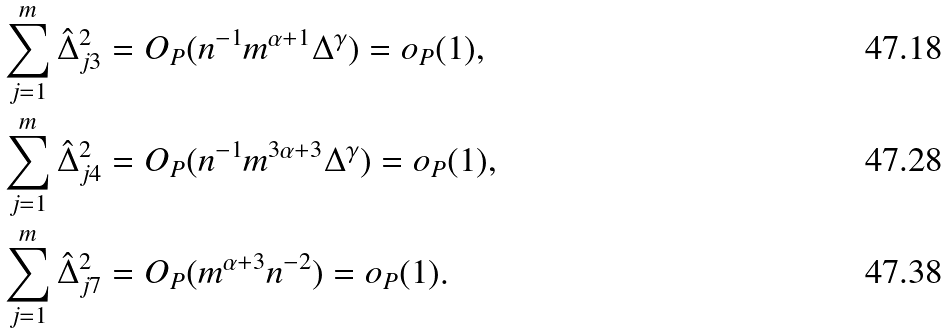Convert formula to latex. <formula><loc_0><loc_0><loc_500><loc_500>\sum _ { j = 1 } ^ { m } \hat { \Delta } _ { j 3 } ^ { 2 } & = O _ { P } ( n ^ { - 1 } m ^ { \alpha + 1 } \Delta ^ { \gamma } ) = o _ { P } ( 1 ) , \\ \sum _ { j = 1 } ^ { m } \hat { \Delta } _ { j 4 } ^ { 2 } & = O _ { P } ( n ^ { - 1 } m ^ { 3 \alpha + 3 } \Delta ^ { \gamma } ) = o _ { P } ( 1 ) , \\ \sum _ { j = 1 } ^ { m } \hat { \Delta } _ { j 7 } ^ { 2 } & = O _ { P } ( m ^ { \alpha + 3 } n ^ { - 2 } ) = o _ { P } ( 1 ) .</formula> 